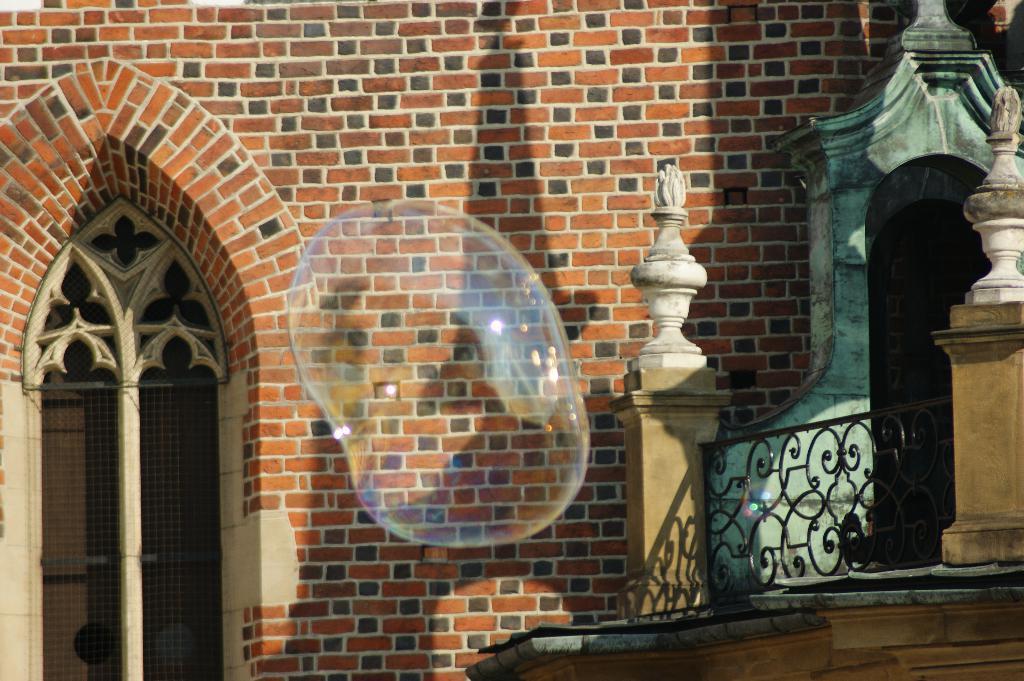Can you describe this image briefly? In the picture I can see a bubble and there is a brick wall which has a window on it is behind the bubble and there is a fence and some other objects in the right corner. 